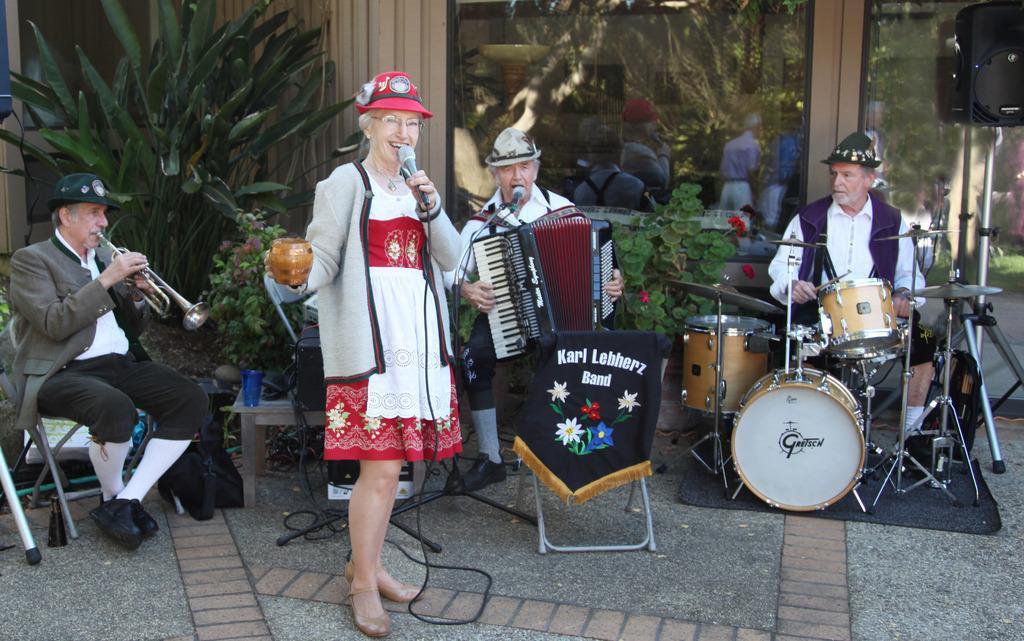Please provide a concise description of this image. This picture shows three men playing musical instruments seated on the chair we see a woman Standing and singing with the help of a microphone in her hand and we see few people standing on their back and we see couple of plants and a man playing drums and other man playing piano and the third man is playing trumpet all the people wore caps on their head 